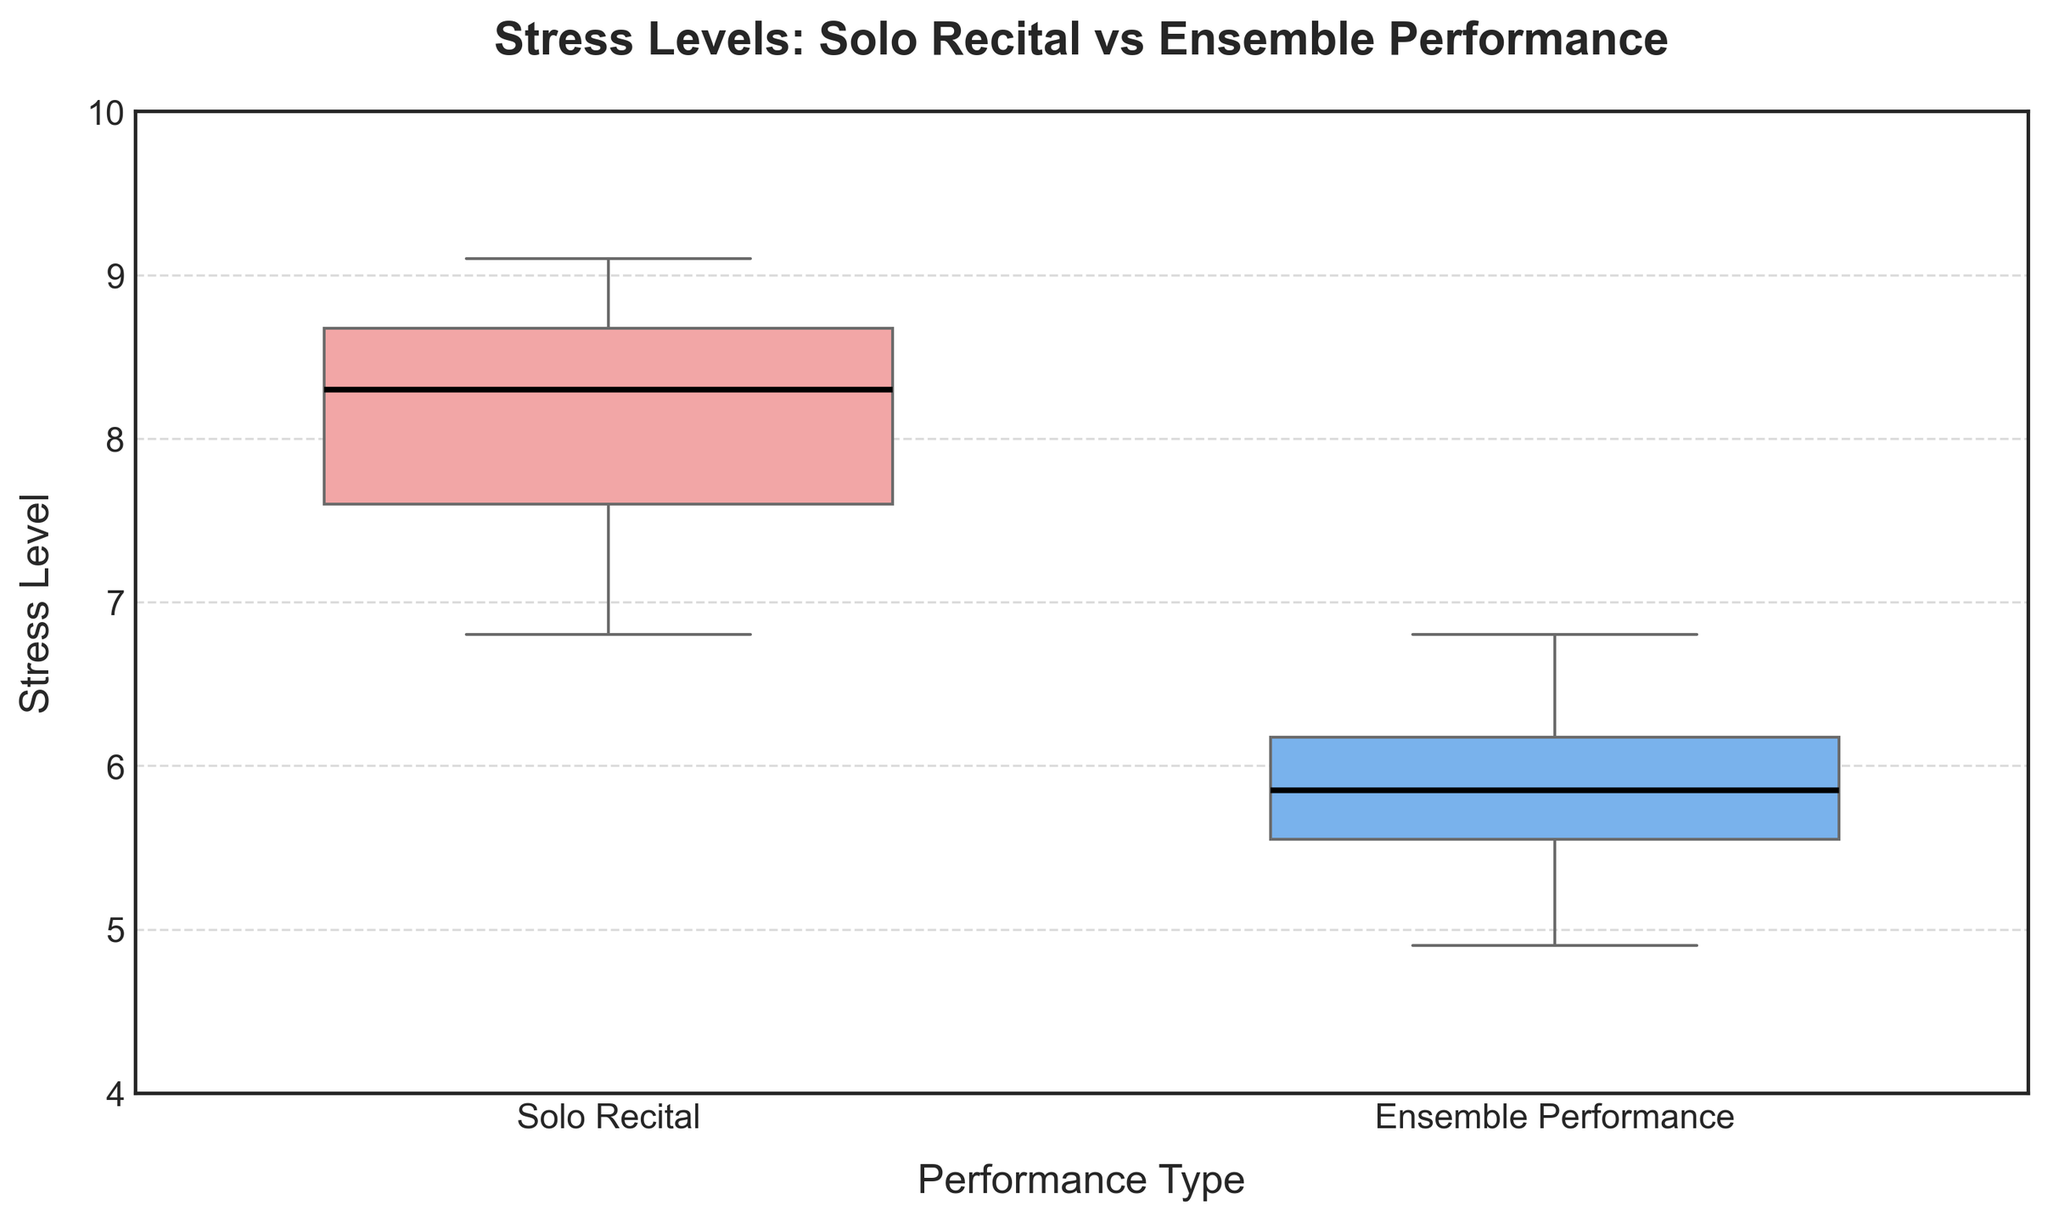What is the title of the plot? The title is usually displayed at the top of the plot and provides a brief description of what the data represents. In this case, the title is "Stress Levels: Solo Recital vs Ensemble Performance".
Answer: Stress Levels: Solo Recital vs Ensemble Performance What are the performance types compared in the plot? The x-axis labels provide the names of the groups being compared. Here, the plot compares "Solo Recital" and "Ensemble Performance".
Answer: Solo Recital and Ensemble Performance What is the median stress level for Solo Recital performances? The median value is indicated by the horizontal black line inside the box for the Solo Recital group.
Answer: Approximately 8.25 In which performance type is the stress level higher overall? The stress levels can be compared by looking at the central tendency and the spread of the data in each box plot. Solo Recital shows a higher central tendency compared to Ensemble Performance.
Answer: Solo Recital What is the range of stress levels for Ensemble Performances? The range is the difference between the maximum and minimum values in the box plot. For Ensemble Performance, the max is around 6.8 and the min is around 4.9. So, the range is 6.8 - 4.9.
Answer: 1.9 How do the interquartile ranges (IQRs) of the two performance types compare? The IQR is the length of the box in the box plot, representing the middle 50% of the data. Comparing the lengths of the boxes, Solo Recital has a larger IQR than Ensemble Performance.
Answer: Solo Recital has a larger IQR Which performance type has the highest stress level outlier? Outliers are indicated by markers outside the whiskers. The highest outlier is a point around 9.1 in the Solo Recital group.
Answer: Solo Recital What are the colors used for each performance type? The colors for each group can be observed from the box plots. Solo Recital uses a shade of red-pink, and Ensemble Performance uses a shade of blue.
Answer: Red-pink for Solo Recital, blue for Ensemble Performance What are the upper and lower quartiles (Q3 and Q1) for Solo Recital? The upper quartile (Q3) is the top of the box, and the lower quartile (Q1) is the bottom of the box for the Solo Recital group. Q3 is about 8.7, and Q1 is about 7.5.
Answer: Q3: 8.7, Q1: 7.5 